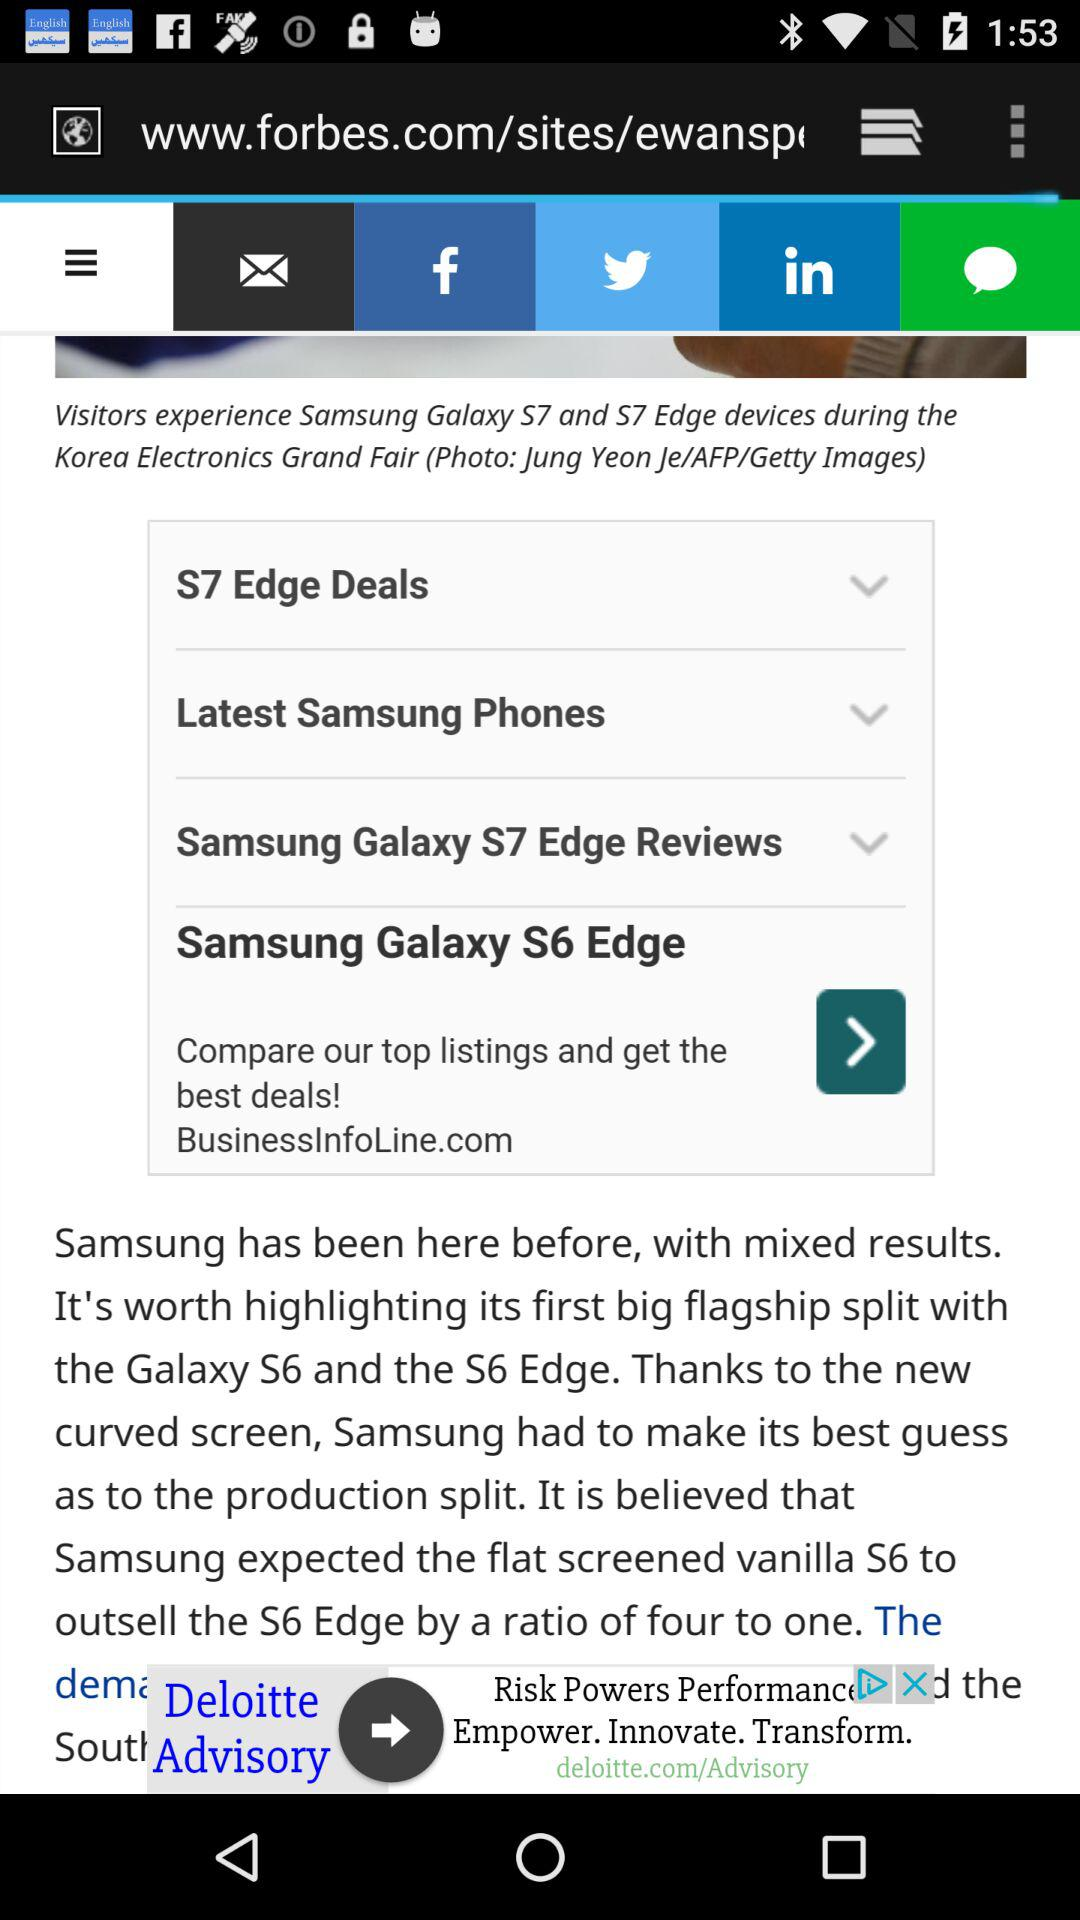What Samsung models highlight the big flagship split? The models are "Galaxy S6" and "S6 Edge". 